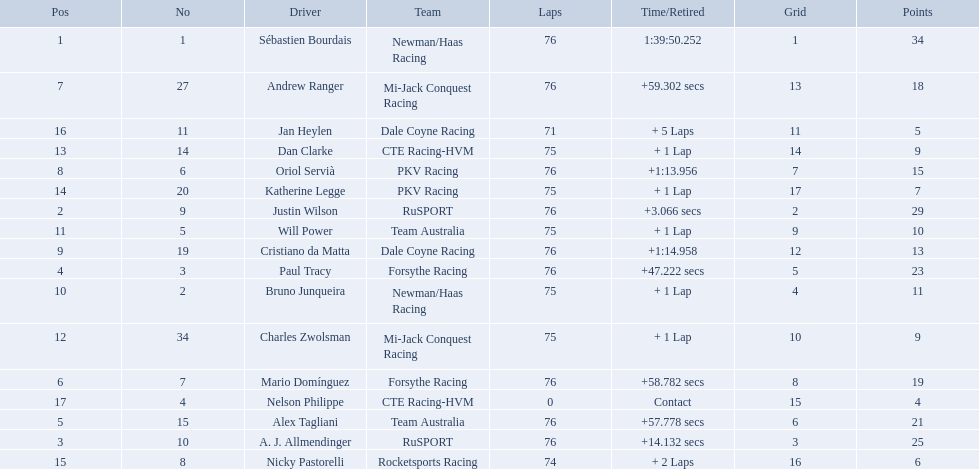Is there a driver named charles zwolsman? Charles Zwolsman. How many points did he acquire? 9. Were there any other entries that got the same number of points? 9. Who did that entry belong to? Dan Clarke. Who drove during the 2006 tecate grand prix of monterrey? Sébastien Bourdais, Justin Wilson, A. J. Allmendinger, Paul Tracy, Alex Tagliani, Mario Domínguez, Andrew Ranger, Oriol Servià, Cristiano da Matta, Bruno Junqueira, Will Power, Charles Zwolsman, Dan Clarke, Katherine Legge, Nicky Pastorelli, Jan Heylen, Nelson Philippe. And what were their finishing positions? 1, 2, 3, 4, 5, 6, 7, 8, 9, 10, 11, 12, 13, 14, 15, 16, 17. Who did alex tagliani finish directly behind of? Paul Tracy. 